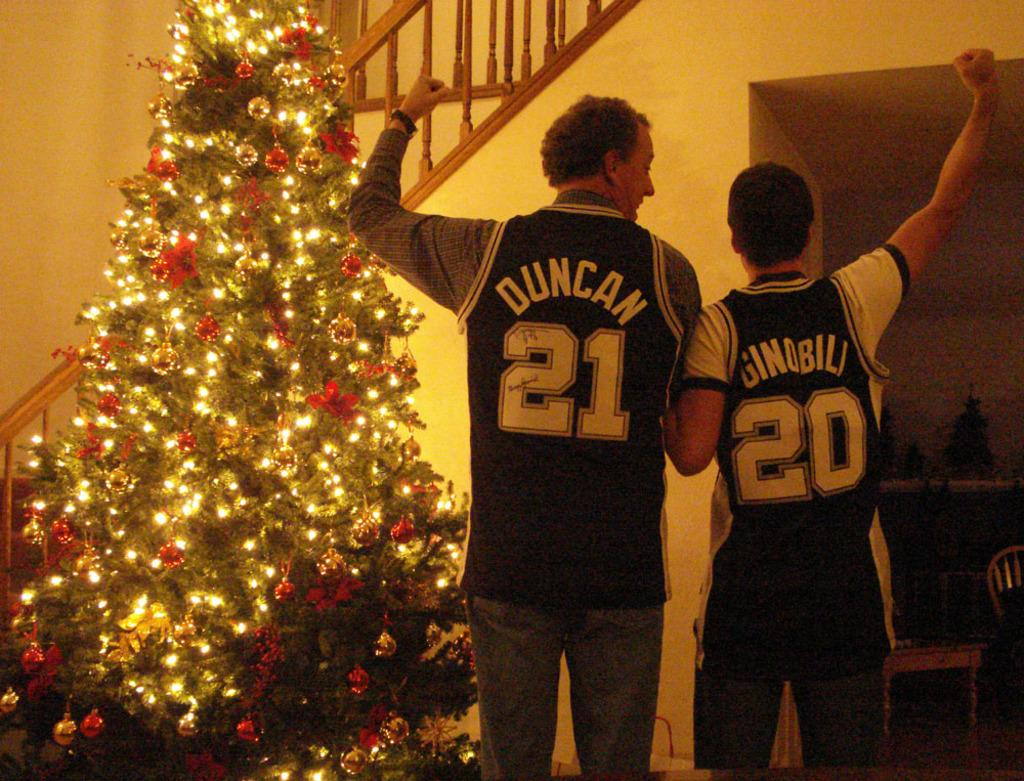<image>
Create a compact narrative representing the image presented. A chritmas tree with two men posing showing off their duncan and hinobili basketball shirts. 